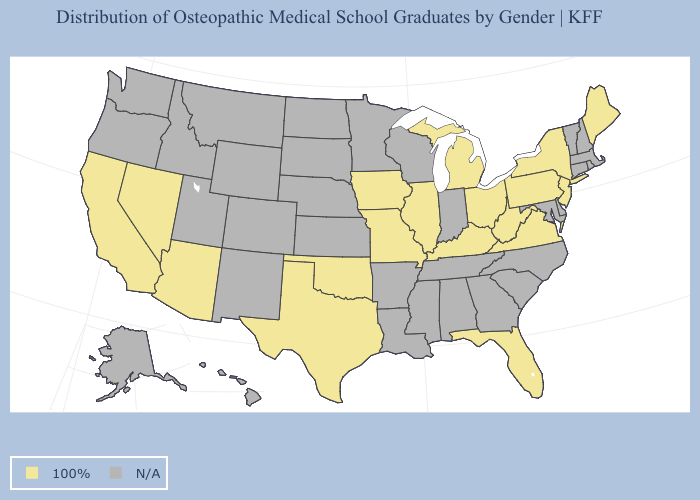Name the states that have a value in the range 100%?
Be succinct. Arizona, California, Florida, Illinois, Iowa, Kentucky, Maine, Michigan, Missouri, Nevada, New Jersey, New York, Ohio, Oklahoma, Pennsylvania, Texas, Virginia, West Virginia. What is the value of Rhode Island?
Answer briefly. N/A. How many symbols are there in the legend?
Answer briefly. 2. Which states have the lowest value in the MidWest?
Answer briefly. Illinois, Iowa, Michigan, Missouri, Ohio. What is the highest value in the West ?
Short answer required. 100%. What is the lowest value in the USA?
Concise answer only. 100%. Which states hav the highest value in the MidWest?
Quick response, please. Illinois, Iowa, Michigan, Missouri, Ohio. Name the states that have a value in the range N/A?
Concise answer only. Alabama, Alaska, Arkansas, Colorado, Connecticut, Delaware, Georgia, Hawaii, Idaho, Indiana, Kansas, Louisiana, Maryland, Massachusetts, Minnesota, Mississippi, Montana, Nebraska, New Hampshire, New Mexico, North Carolina, North Dakota, Oregon, Rhode Island, South Carolina, South Dakota, Tennessee, Utah, Vermont, Washington, Wisconsin, Wyoming. Name the states that have a value in the range 100%?
Be succinct. Arizona, California, Florida, Illinois, Iowa, Kentucky, Maine, Michigan, Missouri, Nevada, New Jersey, New York, Ohio, Oklahoma, Pennsylvania, Texas, Virginia, West Virginia. Does the first symbol in the legend represent the smallest category?
Short answer required. No. 